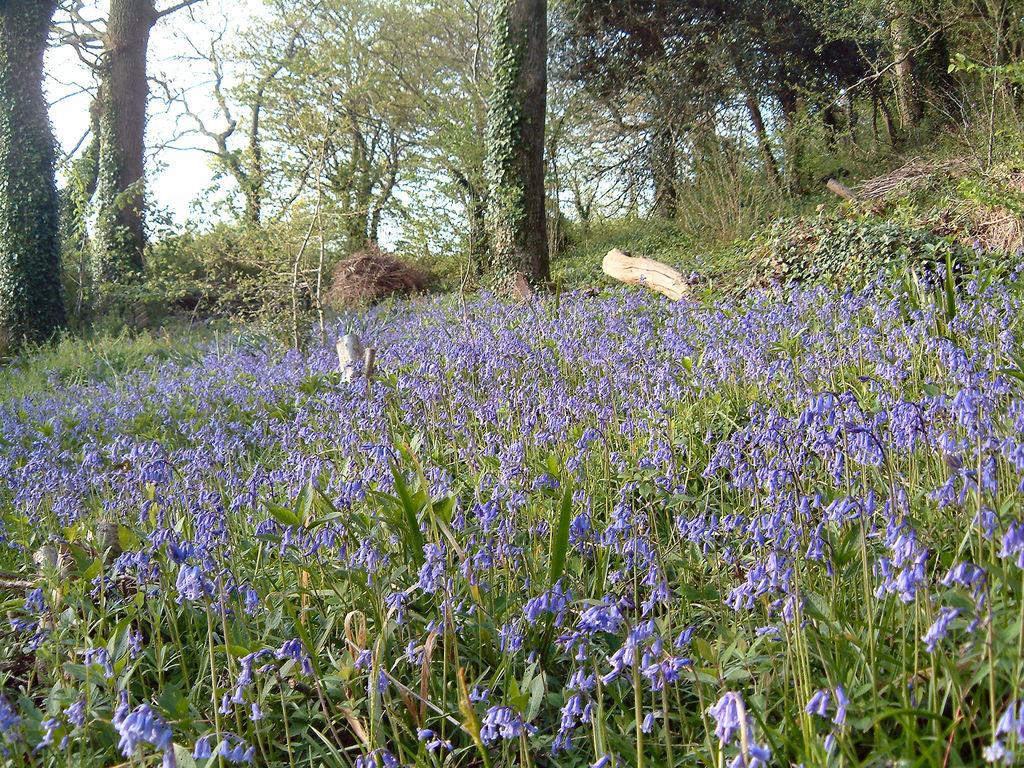What type of plants can be seen in the image? There is a group of plants with flowers in the image. What part of the trees is visible in the image? The bark of trees is visible in the image. Are there any plants that are not in bloom in the image? Yes, there are dried plants in the image. How many groups of trees are present in the image? There is a group of trees in the image. What is the condition of the sky in the image? The sky is visible in the image and appears cloudy. How many frogs can be seen sitting on the bun in the image? There are no frogs or buns present in the image. 